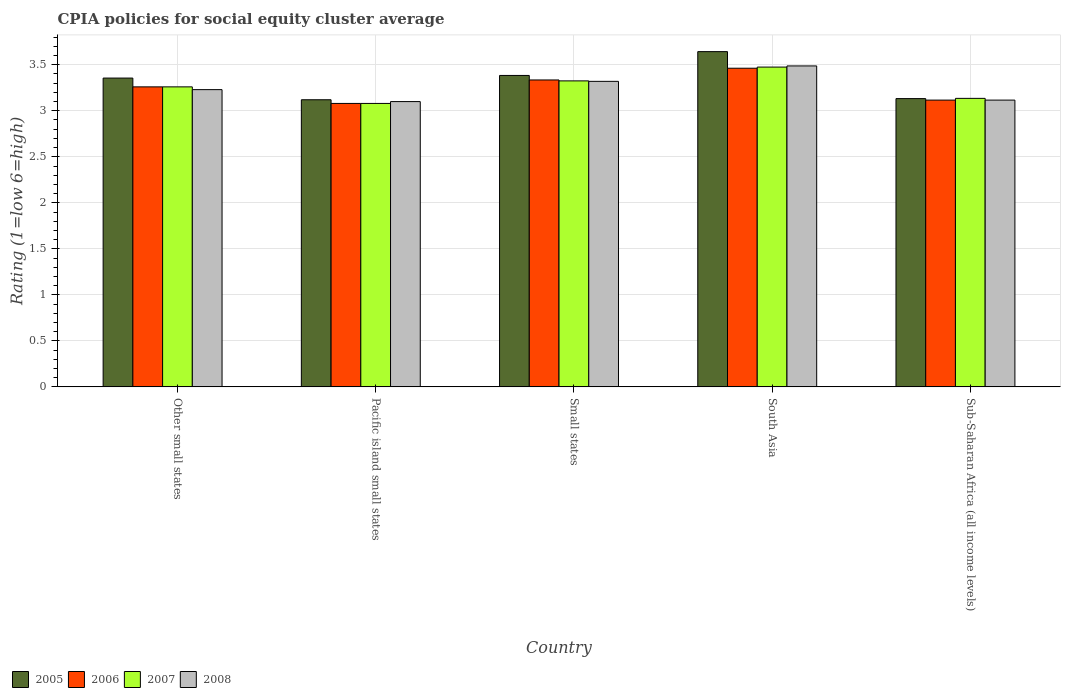How many different coloured bars are there?
Give a very brief answer. 4. How many groups of bars are there?
Offer a terse response. 5. Are the number of bars per tick equal to the number of legend labels?
Give a very brief answer. Yes. Are the number of bars on each tick of the X-axis equal?
Ensure brevity in your answer.  Yes. How many bars are there on the 3rd tick from the left?
Your answer should be very brief. 4. What is the label of the 2nd group of bars from the left?
Give a very brief answer. Pacific island small states. What is the CPIA rating in 2008 in South Asia?
Your answer should be very brief. 3.49. Across all countries, what is the maximum CPIA rating in 2005?
Offer a very short reply. 3.64. Across all countries, what is the minimum CPIA rating in 2007?
Provide a short and direct response. 3.08. In which country was the CPIA rating in 2008 maximum?
Provide a succinct answer. South Asia. In which country was the CPIA rating in 2006 minimum?
Offer a very short reply. Pacific island small states. What is the total CPIA rating in 2005 in the graph?
Your response must be concise. 16.64. What is the difference between the CPIA rating in 2007 in Other small states and that in Pacific island small states?
Provide a short and direct response. 0.18. What is the difference between the CPIA rating in 2005 in Sub-Saharan Africa (all income levels) and the CPIA rating in 2006 in Pacific island small states?
Your response must be concise. 0.05. What is the average CPIA rating in 2008 per country?
Offer a terse response. 3.25. What is the difference between the CPIA rating of/in 2007 and CPIA rating of/in 2008 in South Asia?
Offer a very short reply. -0.01. What is the ratio of the CPIA rating in 2005 in South Asia to that in Sub-Saharan Africa (all income levels)?
Make the answer very short. 1.16. Is the CPIA rating in 2007 in Pacific island small states less than that in Sub-Saharan Africa (all income levels)?
Provide a short and direct response. Yes. What is the difference between the highest and the second highest CPIA rating in 2006?
Provide a short and direct response. -0.13. What is the difference between the highest and the lowest CPIA rating in 2006?
Your answer should be compact. 0.38. Is the sum of the CPIA rating in 2007 in Pacific island small states and Sub-Saharan Africa (all income levels) greater than the maximum CPIA rating in 2005 across all countries?
Make the answer very short. Yes. What does the 3rd bar from the left in South Asia represents?
Make the answer very short. 2007. What does the 3rd bar from the right in Sub-Saharan Africa (all income levels) represents?
Provide a short and direct response. 2006. How many bars are there?
Provide a short and direct response. 20. What is the difference between two consecutive major ticks on the Y-axis?
Your response must be concise. 0.5. Does the graph contain grids?
Your answer should be very brief. Yes. Where does the legend appear in the graph?
Provide a succinct answer. Bottom left. How many legend labels are there?
Offer a very short reply. 4. What is the title of the graph?
Provide a short and direct response. CPIA policies for social equity cluster average. Does "2000" appear as one of the legend labels in the graph?
Your answer should be very brief. No. What is the label or title of the X-axis?
Your answer should be compact. Country. What is the label or title of the Y-axis?
Make the answer very short. Rating (1=low 6=high). What is the Rating (1=low 6=high) of 2005 in Other small states?
Your answer should be compact. 3.36. What is the Rating (1=low 6=high) in 2006 in Other small states?
Ensure brevity in your answer.  3.26. What is the Rating (1=low 6=high) of 2007 in Other small states?
Offer a very short reply. 3.26. What is the Rating (1=low 6=high) in 2008 in Other small states?
Offer a very short reply. 3.23. What is the Rating (1=low 6=high) in 2005 in Pacific island small states?
Make the answer very short. 3.12. What is the Rating (1=low 6=high) in 2006 in Pacific island small states?
Your answer should be compact. 3.08. What is the Rating (1=low 6=high) in 2007 in Pacific island small states?
Your answer should be very brief. 3.08. What is the Rating (1=low 6=high) in 2008 in Pacific island small states?
Keep it short and to the point. 3.1. What is the Rating (1=low 6=high) of 2005 in Small states?
Provide a short and direct response. 3.38. What is the Rating (1=low 6=high) in 2006 in Small states?
Offer a terse response. 3.33. What is the Rating (1=low 6=high) of 2007 in Small states?
Give a very brief answer. 3.33. What is the Rating (1=low 6=high) in 2008 in Small states?
Make the answer very short. 3.32. What is the Rating (1=low 6=high) of 2005 in South Asia?
Give a very brief answer. 3.64. What is the Rating (1=low 6=high) of 2006 in South Asia?
Give a very brief answer. 3.46. What is the Rating (1=low 6=high) in 2007 in South Asia?
Ensure brevity in your answer.  3.48. What is the Rating (1=low 6=high) in 2008 in South Asia?
Offer a terse response. 3.49. What is the Rating (1=low 6=high) in 2005 in Sub-Saharan Africa (all income levels)?
Offer a very short reply. 3.13. What is the Rating (1=low 6=high) in 2006 in Sub-Saharan Africa (all income levels)?
Your answer should be compact. 3.12. What is the Rating (1=low 6=high) in 2007 in Sub-Saharan Africa (all income levels)?
Give a very brief answer. 3.14. What is the Rating (1=low 6=high) of 2008 in Sub-Saharan Africa (all income levels)?
Your response must be concise. 3.12. Across all countries, what is the maximum Rating (1=low 6=high) of 2005?
Keep it short and to the point. 3.64. Across all countries, what is the maximum Rating (1=low 6=high) in 2006?
Provide a succinct answer. 3.46. Across all countries, what is the maximum Rating (1=low 6=high) in 2007?
Provide a succinct answer. 3.48. Across all countries, what is the maximum Rating (1=low 6=high) in 2008?
Give a very brief answer. 3.49. Across all countries, what is the minimum Rating (1=low 6=high) of 2005?
Your answer should be very brief. 3.12. Across all countries, what is the minimum Rating (1=low 6=high) of 2006?
Your answer should be very brief. 3.08. Across all countries, what is the minimum Rating (1=low 6=high) of 2007?
Provide a short and direct response. 3.08. What is the total Rating (1=low 6=high) of 2005 in the graph?
Your response must be concise. 16.64. What is the total Rating (1=low 6=high) in 2006 in the graph?
Offer a very short reply. 16.25. What is the total Rating (1=low 6=high) of 2007 in the graph?
Offer a terse response. 16.28. What is the total Rating (1=low 6=high) in 2008 in the graph?
Provide a succinct answer. 16.25. What is the difference between the Rating (1=low 6=high) of 2005 in Other small states and that in Pacific island small states?
Ensure brevity in your answer.  0.24. What is the difference between the Rating (1=low 6=high) in 2006 in Other small states and that in Pacific island small states?
Give a very brief answer. 0.18. What is the difference between the Rating (1=low 6=high) of 2007 in Other small states and that in Pacific island small states?
Give a very brief answer. 0.18. What is the difference between the Rating (1=low 6=high) of 2008 in Other small states and that in Pacific island small states?
Give a very brief answer. 0.13. What is the difference between the Rating (1=low 6=high) of 2005 in Other small states and that in Small states?
Ensure brevity in your answer.  -0.03. What is the difference between the Rating (1=low 6=high) in 2006 in Other small states and that in Small states?
Provide a succinct answer. -0.07. What is the difference between the Rating (1=low 6=high) of 2007 in Other small states and that in Small states?
Make the answer very short. -0.07. What is the difference between the Rating (1=low 6=high) in 2008 in Other small states and that in Small states?
Keep it short and to the point. -0.09. What is the difference between the Rating (1=low 6=high) in 2005 in Other small states and that in South Asia?
Provide a succinct answer. -0.29. What is the difference between the Rating (1=low 6=high) of 2006 in Other small states and that in South Asia?
Offer a very short reply. -0.2. What is the difference between the Rating (1=low 6=high) of 2007 in Other small states and that in South Asia?
Your response must be concise. -0.21. What is the difference between the Rating (1=low 6=high) of 2008 in Other small states and that in South Asia?
Ensure brevity in your answer.  -0.26. What is the difference between the Rating (1=low 6=high) in 2005 in Other small states and that in Sub-Saharan Africa (all income levels)?
Your response must be concise. 0.22. What is the difference between the Rating (1=low 6=high) of 2006 in Other small states and that in Sub-Saharan Africa (all income levels)?
Ensure brevity in your answer.  0.14. What is the difference between the Rating (1=low 6=high) of 2007 in Other small states and that in Sub-Saharan Africa (all income levels)?
Ensure brevity in your answer.  0.12. What is the difference between the Rating (1=low 6=high) of 2008 in Other small states and that in Sub-Saharan Africa (all income levels)?
Ensure brevity in your answer.  0.11. What is the difference between the Rating (1=low 6=high) in 2005 in Pacific island small states and that in Small states?
Offer a terse response. -0.26. What is the difference between the Rating (1=low 6=high) of 2006 in Pacific island small states and that in Small states?
Your answer should be compact. -0.26. What is the difference between the Rating (1=low 6=high) in 2007 in Pacific island small states and that in Small states?
Your answer should be compact. -0.24. What is the difference between the Rating (1=low 6=high) of 2008 in Pacific island small states and that in Small states?
Offer a terse response. -0.22. What is the difference between the Rating (1=low 6=high) of 2005 in Pacific island small states and that in South Asia?
Offer a very short reply. -0.52. What is the difference between the Rating (1=low 6=high) in 2006 in Pacific island small states and that in South Asia?
Ensure brevity in your answer.  -0.38. What is the difference between the Rating (1=low 6=high) in 2007 in Pacific island small states and that in South Asia?
Ensure brevity in your answer.  -0.4. What is the difference between the Rating (1=low 6=high) in 2008 in Pacific island small states and that in South Asia?
Provide a short and direct response. -0.39. What is the difference between the Rating (1=low 6=high) in 2005 in Pacific island small states and that in Sub-Saharan Africa (all income levels)?
Provide a succinct answer. -0.01. What is the difference between the Rating (1=low 6=high) in 2006 in Pacific island small states and that in Sub-Saharan Africa (all income levels)?
Offer a terse response. -0.04. What is the difference between the Rating (1=low 6=high) in 2007 in Pacific island small states and that in Sub-Saharan Africa (all income levels)?
Ensure brevity in your answer.  -0.06. What is the difference between the Rating (1=low 6=high) in 2008 in Pacific island small states and that in Sub-Saharan Africa (all income levels)?
Ensure brevity in your answer.  -0.02. What is the difference between the Rating (1=low 6=high) of 2005 in Small states and that in South Asia?
Give a very brief answer. -0.26. What is the difference between the Rating (1=low 6=high) of 2006 in Small states and that in South Asia?
Offer a very short reply. -0.13. What is the difference between the Rating (1=low 6=high) of 2008 in Small states and that in South Asia?
Your answer should be compact. -0.17. What is the difference between the Rating (1=low 6=high) in 2005 in Small states and that in Sub-Saharan Africa (all income levels)?
Offer a very short reply. 0.25. What is the difference between the Rating (1=low 6=high) in 2006 in Small states and that in Sub-Saharan Africa (all income levels)?
Offer a terse response. 0.22. What is the difference between the Rating (1=low 6=high) in 2007 in Small states and that in Sub-Saharan Africa (all income levels)?
Keep it short and to the point. 0.19. What is the difference between the Rating (1=low 6=high) in 2008 in Small states and that in Sub-Saharan Africa (all income levels)?
Your answer should be very brief. 0.2. What is the difference between the Rating (1=low 6=high) in 2005 in South Asia and that in Sub-Saharan Africa (all income levels)?
Your answer should be compact. 0.51. What is the difference between the Rating (1=low 6=high) in 2006 in South Asia and that in Sub-Saharan Africa (all income levels)?
Your answer should be very brief. 0.35. What is the difference between the Rating (1=low 6=high) of 2007 in South Asia and that in Sub-Saharan Africa (all income levels)?
Your answer should be compact. 0.34. What is the difference between the Rating (1=low 6=high) in 2008 in South Asia and that in Sub-Saharan Africa (all income levels)?
Offer a terse response. 0.37. What is the difference between the Rating (1=low 6=high) of 2005 in Other small states and the Rating (1=low 6=high) of 2006 in Pacific island small states?
Make the answer very short. 0.28. What is the difference between the Rating (1=low 6=high) in 2005 in Other small states and the Rating (1=low 6=high) in 2007 in Pacific island small states?
Make the answer very short. 0.28. What is the difference between the Rating (1=low 6=high) of 2005 in Other small states and the Rating (1=low 6=high) of 2008 in Pacific island small states?
Your answer should be very brief. 0.26. What is the difference between the Rating (1=low 6=high) of 2006 in Other small states and the Rating (1=low 6=high) of 2007 in Pacific island small states?
Keep it short and to the point. 0.18. What is the difference between the Rating (1=low 6=high) in 2006 in Other small states and the Rating (1=low 6=high) in 2008 in Pacific island small states?
Provide a succinct answer. 0.16. What is the difference between the Rating (1=low 6=high) in 2007 in Other small states and the Rating (1=low 6=high) in 2008 in Pacific island small states?
Ensure brevity in your answer.  0.16. What is the difference between the Rating (1=low 6=high) in 2005 in Other small states and the Rating (1=low 6=high) in 2006 in Small states?
Provide a succinct answer. 0.02. What is the difference between the Rating (1=low 6=high) of 2005 in Other small states and the Rating (1=low 6=high) of 2007 in Small states?
Keep it short and to the point. 0.03. What is the difference between the Rating (1=low 6=high) in 2005 in Other small states and the Rating (1=low 6=high) in 2008 in Small states?
Offer a terse response. 0.04. What is the difference between the Rating (1=low 6=high) of 2006 in Other small states and the Rating (1=low 6=high) of 2007 in Small states?
Provide a short and direct response. -0.07. What is the difference between the Rating (1=low 6=high) of 2006 in Other small states and the Rating (1=low 6=high) of 2008 in Small states?
Make the answer very short. -0.06. What is the difference between the Rating (1=low 6=high) of 2007 in Other small states and the Rating (1=low 6=high) of 2008 in Small states?
Your response must be concise. -0.06. What is the difference between the Rating (1=low 6=high) of 2005 in Other small states and the Rating (1=low 6=high) of 2006 in South Asia?
Your answer should be very brief. -0.11. What is the difference between the Rating (1=low 6=high) in 2005 in Other small states and the Rating (1=low 6=high) in 2007 in South Asia?
Your response must be concise. -0.12. What is the difference between the Rating (1=low 6=high) of 2005 in Other small states and the Rating (1=low 6=high) of 2008 in South Asia?
Provide a short and direct response. -0.13. What is the difference between the Rating (1=low 6=high) in 2006 in Other small states and the Rating (1=low 6=high) in 2007 in South Asia?
Provide a short and direct response. -0.21. What is the difference between the Rating (1=low 6=high) of 2006 in Other small states and the Rating (1=low 6=high) of 2008 in South Asia?
Provide a succinct answer. -0.23. What is the difference between the Rating (1=low 6=high) in 2007 in Other small states and the Rating (1=low 6=high) in 2008 in South Asia?
Your answer should be compact. -0.23. What is the difference between the Rating (1=low 6=high) in 2005 in Other small states and the Rating (1=low 6=high) in 2006 in Sub-Saharan Africa (all income levels)?
Keep it short and to the point. 0.24. What is the difference between the Rating (1=low 6=high) in 2005 in Other small states and the Rating (1=low 6=high) in 2007 in Sub-Saharan Africa (all income levels)?
Your answer should be compact. 0.22. What is the difference between the Rating (1=low 6=high) in 2005 in Other small states and the Rating (1=low 6=high) in 2008 in Sub-Saharan Africa (all income levels)?
Make the answer very short. 0.24. What is the difference between the Rating (1=low 6=high) of 2006 in Other small states and the Rating (1=low 6=high) of 2007 in Sub-Saharan Africa (all income levels)?
Your answer should be compact. 0.12. What is the difference between the Rating (1=low 6=high) of 2006 in Other small states and the Rating (1=low 6=high) of 2008 in Sub-Saharan Africa (all income levels)?
Give a very brief answer. 0.14. What is the difference between the Rating (1=low 6=high) of 2007 in Other small states and the Rating (1=low 6=high) of 2008 in Sub-Saharan Africa (all income levels)?
Keep it short and to the point. 0.14. What is the difference between the Rating (1=low 6=high) of 2005 in Pacific island small states and the Rating (1=low 6=high) of 2006 in Small states?
Provide a short and direct response. -0.21. What is the difference between the Rating (1=low 6=high) of 2005 in Pacific island small states and the Rating (1=low 6=high) of 2007 in Small states?
Your answer should be compact. -0.2. What is the difference between the Rating (1=low 6=high) in 2006 in Pacific island small states and the Rating (1=low 6=high) in 2007 in Small states?
Offer a terse response. -0.24. What is the difference between the Rating (1=low 6=high) of 2006 in Pacific island small states and the Rating (1=low 6=high) of 2008 in Small states?
Provide a succinct answer. -0.24. What is the difference between the Rating (1=low 6=high) of 2007 in Pacific island small states and the Rating (1=low 6=high) of 2008 in Small states?
Keep it short and to the point. -0.24. What is the difference between the Rating (1=low 6=high) in 2005 in Pacific island small states and the Rating (1=low 6=high) in 2006 in South Asia?
Keep it short and to the point. -0.34. What is the difference between the Rating (1=low 6=high) in 2005 in Pacific island small states and the Rating (1=low 6=high) in 2007 in South Asia?
Provide a short and direct response. -0.35. What is the difference between the Rating (1=low 6=high) in 2005 in Pacific island small states and the Rating (1=low 6=high) in 2008 in South Asia?
Provide a short and direct response. -0.37. What is the difference between the Rating (1=low 6=high) of 2006 in Pacific island small states and the Rating (1=low 6=high) of 2007 in South Asia?
Your answer should be very brief. -0.4. What is the difference between the Rating (1=low 6=high) of 2006 in Pacific island small states and the Rating (1=low 6=high) of 2008 in South Asia?
Provide a succinct answer. -0.41. What is the difference between the Rating (1=low 6=high) of 2007 in Pacific island small states and the Rating (1=low 6=high) of 2008 in South Asia?
Make the answer very short. -0.41. What is the difference between the Rating (1=low 6=high) in 2005 in Pacific island small states and the Rating (1=low 6=high) in 2006 in Sub-Saharan Africa (all income levels)?
Ensure brevity in your answer.  0. What is the difference between the Rating (1=low 6=high) in 2005 in Pacific island small states and the Rating (1=low 6=high) in 2007 in Sub-Saharan Africa (all income levels)?
Offer a terse response. -0.02. What is the difference between the Rating (1=low 6=high) in 2005 in Pacific island small states and the Rating (1=low 6=high) in 2008 in Sub-Saharan Africa (all income levels)?
Your answer should be very brief. 0. What is the difference between the Rating (1=low 6=high) in 2006 in Pacific island small states and the Rating (1=low 6=high) in 2007 in Sub-Saharan Africa (all income levels)?
Give a very brief answer. -0.06. What is the difference between the Rating (1=low 6=high) in 2006 in Pacific island small states and the Rating (1=low 6=high) in 2008 in Sub-Saharan Africa (all income levels)?
Provide a succinct answer. -0.04. What is the difference between the Rating (1=low 6=high) in 2007 in Pacific island small states and the Rating (1=low 6=high) in 2008 in Sub-Saharan Africa (all income levels)?
Offer a terse response. -0.04. What is the difference between the Rating (1=low 6=high) in 2005 in Small states and the Rating (1=low 6=high) in 2006 in South Asia?
Give a very brief answer. -0.08. What is the difference between the Rating (1=low 6=high) of 2005 in Small states and the Rating (1=low 6=high) of 2007 in South Asia?
Offer a terse response. -0.09. What is the difference between the Rating (1=low 6=high) of 2005 in Small states and the Rating (1=low 6=high) of 2008 in South Asia?
Keep it short and to the point. -0.1. What is the difference between the Rating (1=low 6=high) in 2006 in Small states and the Rating (1=low 6=high) in 2007 in South Asia?
Your answer should be compact. -0.14. What is the difference between the Rating (1=low 6=high) in 2006 in Small states and the Rating (1=low 6=high) in 2008 in South Asia?
Provide a succinct answer. -0.15. What is the difference between the Rating (1=low 6=high) in 2007 in Small states and the Rating (1=low 6=high) in 2008 in South Asia?
Your response must be concise. -0.16. What is the difference between the Rating (1=low 6=high) of 2005 in Small states and the Rating (1=low 6=high) of 2006 in Sub-Saharan Africa (all income levels)?
Your answer should be compact. 0.27. What is the difference between the Rating (1=low 6=high) of 2005 in Small states and the Rating (1=low 6=high) of 2007 in Sub-Saharan Africa (all income levels)?
Provide a short and direct response. 0.25. What is the difference between the Rating (1=low 6=high) of 2005 in Small states and the Rating (1=low 6=high) of 2008 in Sub-Saharan Africa (all income levels)?
Your response must be concise. 0.27. What is the difference between the Rating (1=low 6=high) of 2006 in Small states and the Rating (1=low 6=high) of 2007 in Sub-Saharan Africa (all income levels)?
Give a very brief answer. 0.2. What is the difference between the Rating (1=low 6=high) of 2006 in Small states and the Rating (1=low 6=high) of 2008 in Sub-Saharan Africa (all income levels)?
Your answer should be compact. 0.22. What is the difference between the Rating (1=low 6=high) of 2007 in Small states and the Rating (1=low 6=high) of 2008 in Sub-Saharan Africa (all income levels)?
Your answer should be very brief. 0.21. What is the difference between the Rating (1=low 6=high) in 2005 in South Asia and the Rating (1=low 6=high) in 2006 in Sub-Saharan Africa (all income levels)?
Offer a very short reply. 0.53. What is the difference between the Rating (1=low 6=high) in 2005 in South Asia and the Rating (1=low 6=high) in 2007 in Sub-Saharan Africa (all income levels)?
Give a very brief answer. 0.51. What is the difference between the Rating (1=low 6=high) in 2005 in South Asia and the Rating (1=low 6=high) in 2008 in Sub-Saharan Africa (all income levels)?
Keep it short and to the point. 0.53. What is the difference between the Rating (1=low 6=high) in 2006 in South Asia and the Rating (1=low 6=high) in 2007 in Sub-Saharan Africa (all income levels)?
Offer a very short reply. 0.33. What is the difference between the Rating (1=low 6=high) of 2006 in South Asia and the Rating (1=low 6=high) of 2008 in Sub-Saharan Africa (all income levels)?
Provide a short and direct response. 0.35. What is the difference between the Rating (1=low 6=high) in 2007 in South Asia and the Rating (1=low 6=high) in 2008 in Sub-Saharan Africa (all income levels)?
Provide a succinct answer. 0.36. What is the average Rating (1=low 6=high) of 2005 per country?
Make the answer very short. 3.33. What is the average Rating (1=low 6=high) in 2006 per country?
Offer a terse response. 3.25. What is the average Rating (1=low 6=high) of 2007 per country?
Provide a succinct answer. 3.25. What is the average Rating (1=low 6=high) of 2008 per country?
Your response must be concise. 3.25. What is the difference between the Rating (1=low 6=high) of 2005 and Rating (1=low 6=high) of 2006 in Other small states?
Provide a succinct answer. 0.1. What is the difference between the Rating (1=low 6=high) in 2005 and Rating (1=low 6=high) in 2007 in Other small states?
Provide a succinct answer. 0.1. What is the difference between the Rating (1=low 6=high) of 2005 and Rating (1=low 6=high) of 2008 in Other small states?
Give a very brief answer. 0.13. What is the difference between the Rating (1=low 6=high) in 2006 and Rating (1=low 6=high) in 2008 in Other small states?
Your answer should be very brief. 0.03. What is the difference between the Rating (1=low 6=high) of 2005 and Rating (1=low 6=high) of 2006 in Pacific island small states?
Make the answer very short. 0.04. What is the difference between the Rating (1=low 6=high) in 2005 and Rating (1=low 6=high) in 2007 in Pacific island small states?
Make the answer very short. 0.04. What is the difference between the Rating (1=low 6=high) in 2005 and Rating (1=low 6=high) in 2008 in Pacific island small states?
Offer a terse response. 0.02. What is the difference between the Rating (1=low 6=high) of 2006 and Rating (1=low 6=high) of 2007 in Pacific island small states?
Offer a terse response. 0. What is the difference between the Rating (1=low 6=high) in 2006 and Rating (1=low 6=high) in 2008 in Pacific island small states?
Provide a short and direct response. -0.02. What is the difference between the Rating (1=low 6=high) in 2007 and Rating (1=low 6=high) in 2008 in Pacific island small states?
Offer a very short reply. -0.02. What is the difference between the Rating (1=low 6=high) in 2005 and Rating (1=low 6=high) in 2006 in Small states?
Your answer should be very brief. 0.05. What is the difference between the Rating (1=low 6=high) of 2005 and Rating (1=low 6=high) of 2007 in Small states?
Ensure brevity in your answer.  0.06. What is the difference between the Rating (1=low 6=high) of 2005 and Rating (1=low 6=high) of 2008 in Small states?
Your response must be concise. 0.06. What is the difference between the Rating (1=low 6=high) in 2006 and Rating (1=low 6=high) in 2007 in Small states?
Offer a very short reply. 0.01. What is the difference between the Rating (1=low 6=high) in 2006 and Rating (1=low 6=high) in 2008 in Small states?
Your answer should be very brief. 0.01. What is the difference between the Rating (1=low 6=high) of 2007 and Rating (1=low 6=high) of 2008 in Small states?
Your response must be concise. 0.01. What is the difference between the Rating (1=low 6=high) in 2005 and Rating (1=low 6=high) in 2006 in South Asia?
Give a very brief answer. 0.18. What is the difference between the Rating (1=low 6=high) of 2005 and Rating (1=low 6=high) of 2007 in South Asia?
Make the answer very short. 0.17. What is the difference between the Rating (1=low 6=high) in 2005 and Rating (1=low 6=high) in 2008 in South Asia?
Your answer should be very brief. 0.16. What is the difference between the Rating (1=low 6=high) of 2006 and Rating (1=low 6=high) of 2007 in South Asia?
Keep it short and to the point. -0.01. What is the difference between the Rating (1=low 6=high) in 2006 and Rating (1=low 6=high) in 2008 in South Asia?
Offer a very short reply. -0.03. What is the difference between the Rating (1=low 6=high) of 2007 and Rating (1=low 6=high) of 2008 in South Asia?
Give a very brief answer. -0.01. What is the difference between the Rating (1=low 6=high) in 2005 and Rating (1=low 6=high) in 2006 in Sub-Saharan Africa (all income levels)?
Make the answer very short. 0.02. What is the difference between the Rating (1=low 6=high) in 2005 and Rating (1=low 6=high) in 2007 in Sub-Saharan Africa (all income levels)?
Your answer should be very brief. -0. What is the difference between the Rating (1=low 6=high) of 2005 and Rating (1=low 6=high) of 2008 in Sub-Saharan Africa (all income levels)?
Give a very brief answer. 0.02. What is the difference between the Rating (1=low 6=high) in 2006 and Rating (1=low 6=high) in 2007 in Sub-Saharan Africa (all income levels)?
Your response must be concise. -0.02. What is the difference between the Rating (1=low 6=high) in 2007 and Rating (1=low 6=high) in 2008 in Sub-Saharan Africa (all income levels)?
Ensure brevity in your answer.  0.02. What is the ratio of the Rating (1=low 6=high) in 2005 in Other small states to that in Pacific island small states?
Provide a short and direct response. 1.08. What is the ratio of the Rating (1=low 6=high) in 2006 in Other small states to that in Pacific island small states?
Provide a succinct answer. 1.06. What is the ratio of the Rating (1=low 6=high) of 2007 in Other small states to that in Pacific island small states?
Offer a very short reply. 1.06. What is the ratio of the Rating (1=low 6=high) of 2008 in Other small states to that in Pacific island small states?
Give a very brief answer. 1.04. What is the ratio of the Rating (1=low 6=high) of 2005 in Other small states to that in Small states?
Your answer should be compact. 0.99. What is the ratio of the Rating (1=low 6=high) of 2006 in Other small states to that in Small states?
Your answer should be very brief. 0.98. What is the ratio of the Rating (1=low 6=high) of 2007 in Other small states to that in Small states?
Your answer should be very brief. 0.98. What is the ratio of the Rating (1=low 6=high) in 2008 in Other small states to that in Small states?
Offer a very short reply. 0.97. What is the ratio of the Rating (1=low 6=high) in 2005 in Other small states to that in South Asia?
Offer a very short reply. 0.92. What is the ratio of the Rating (1=low 6=high) in 2006 in Other small states to that in South Asia?
Ensure brevity in your answer.  0.94. What is the ratio of the Rating (1=low 6=high) in 2007 in Other small states to that in South Asia?
Your answer should be very brief. 0.94. What is the ratio of the Rating (1=low 6=high) of 2008 in Other small states to that in South Asia?
Your answer should be very brief. 0.93. What is the ratio of the Rating (1=low 6=high) in 2005 in Other small states to that in Sub-Saharan Africa (all income levels)?
Give a very brief answer. 1.07. What is the ratio of the Rating (1=low 6=high) of 2006 in Other small states to that in Sub-Saharan Africa (all income levels)?
Your answer should be very brief. 1.05. What is the ratio of the Rating (1=low 6=high) in 2007 in Other small states to that in Sub-Saharan Africa (all income levels)?
Give a very brief answer. 1.04. What is the ratio of the Rating (1=low 6=high) in 2008 in Other small states to that in Sub-Saharan Africa (all income levels)?
Your response must be concise. 1.04. What is the ratio of the Rating (1=low 6=high) in 2005 in Pacific island small states to that in Small states?
Your answer should be very brief. 0.92. What is the ratio of the Rating (1=low 6=high) in 2006 in Pacific island small states to that in Small states?
Your answer should be very brief. 0.92. What is the ratio of the Rating (1=low 6=high) in 2007 in Pacific island small states to that in Small states?
Provide a succinct answer. 0.93. What is the ratio of the Rating (1=low 6=high) of 2008 in Pacific island small states to that in Small states?
Provide a succinct answer. 0.93. What is the ratio of the Rating (1=low 6=high) in 2005 in Pacific island small states to that in South Asia?
Provide a short and direct response. 0.86. What is the ratio of the Rating (1=low 6=high) of 2006 in Pacific island small states to that in South Asia?
Keep it short and to the point. 0.89. What is the ratio of the Rating (1=low 6=high) of 2007 in Pacific island small states to that in South Asia?
Your answer should be compact. 0.89. What is the ratio of the Rating (1=low 6=high) of 2008 in Pacific island small states to that in South Asia?
Provide a short and direct response. 0.89. What is the ratio of the Rating (1=low 6=high) in 2005 in Pacific island small states to that in Sub-Saharan Africa (all income levels)?
Offer a terse response. 1. What is the ratio of the Rating (1=low 6=high) of 2006 in Pacific island small states to that in Sub-Saharan Africa (all income levels)?
Keep it short and to the point. 0.99. What is the ratio of the Rating (1=low 6=high) in 2007 in Pacific island small states to that in Sub-Saharan Africa (all income levels)?
Keep it short and to the point. 0.98. What is the ratio of the Rating (1=low 6=high) in 2005 in Small states to that in South Asia?
Ensure brevity in your answer.  0.93. What is the ratio of the Rating (1=low 6=high) in 2006 in Small states to that in South Asia?
Offer a very short reply. 0.96. What is the ratio of the Rating (1=low 6=high) of 2007 in Small states to that in South Asia?
Ensure brevity in your answer.  0.96. What is the ratio of the Rating (1=low 6=high) of 2005 in Small states to that in Sub-Saharan Africa (all income levels)?
Make the answer very short. 1.08. What is the ratio of the Rating (1=low 6=high) in 2006 in Small states to that in Sub-Saharan Africa (all income levels)?
Your answer should be compact. 1.07. What is the ratio of the Rating (1=low 6=high) in 2007 in Small states to that in Sub-Saharan Africa (all income levels)?
Your answer should be very brief. 1.06. What is the ratio of the Rating (1=low 6=high) of 2008 in Small states to that in Sub-Saharan Africa (all income levels)?
Your answer should be compact. 1.07. What is the ratio of the Rating (1=low 6=high) in 2005 in South Asia to that in Sub-Saharan Africa (all income levels)?
Your answer should be compact. 1.16. What is the ratio of the Rating (1=low 6=high) of 2007 in South Asia to that in Sub-Saharan Africa (all income levels)?
Your answer should be very brief. 1.11. What is the ratio of the Rating (1=low 6=high) in 2008 in South Asia to that in Sub-Saharan Africa (all income levels)?
Offer a terse response. 1.12. What is the difference between the highest and the second highest Rating (1=low 6=high) in 2005?
Keep it short and to the point. 0.26. What is the difference between the highest and the second highest Rating (1=low 6=high) of 2006?
Offer a terse response. 0.13. What is the difference between the highest and the second highest Rating (1=low 6=high) of 2007?
Provide a short and direct response. 0.15. What is the difference between the highest and the second highest Rating (1=low 6=high) of 2008?
Your answer should be compact. 0.17. What is the difference between the highest and the lowest Rating (1=low 6=high) of 2005?
Your answer should be very brief. 0.52. What is the difference between the highest and the lowest Rating (1=low 6=high) of 2006?
Provide a succinct answer. 0.38. What is the difference between the highest and the lowest Rating (1=low 6=high) of 2007?
Provide a succinct answer. 0.4. What is the difference between the highest and the lowest Rating (1=low 6=high) of 2008?
Offer a very short reply. 0.39. 